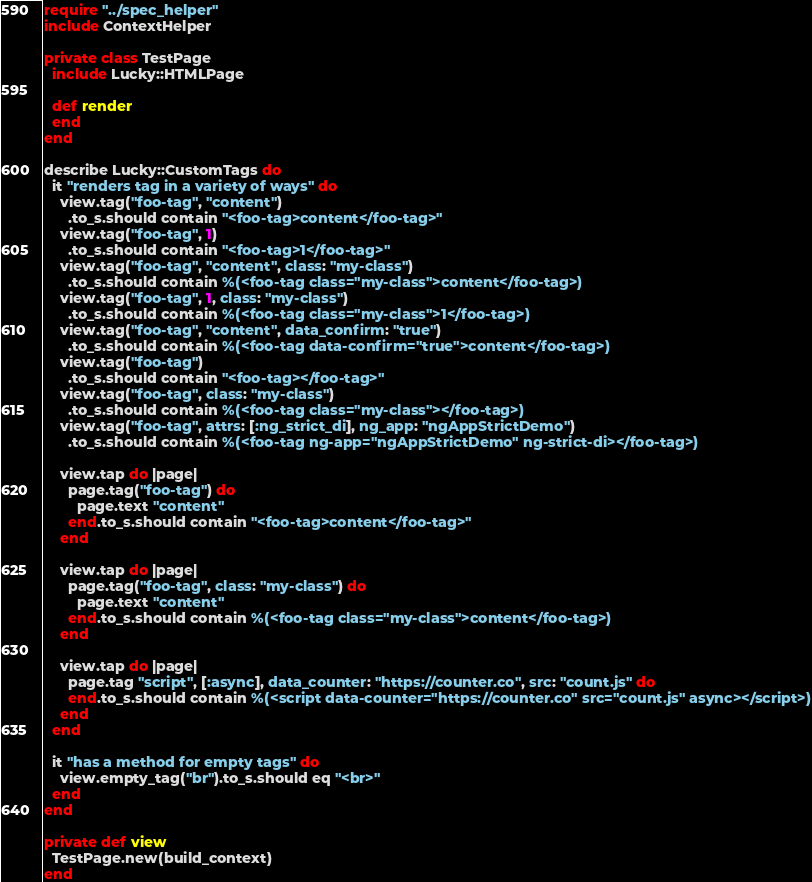Convert code to text. <code><loc_0><loc_0><loc_500><loc_500><_Crystal_>require "../spec_helper"
include ContextHelper

private class TestPage
  include Lucky::HTMLPage

  def render
  end
end

describe Lucky::CustomTags do
  it "renders tag in a variety of ways" do
    view.tag("foo-tag", "content")
      .to_s.should contain "<foo-tag>content</foo-tag>"
    view.tag("foo-tag", 1)
      .to_s.should contain "<foo-tag>1</foo-tag>"
    view.tag("foo-tag", "content", class: "my-class")
      .to_s.should contain %(<foo-tag class="my-class">content</foo-tag>)
    view.tag("foo-tag", 1, class: "my-class")
      .to_s.should contain %(<foo-tag class="my-class">1</foo-tag>)
    view.tag("foo-tag", "content", data_confirm: "true")
      .to_s.should contain %(<foo-tag data-confirm="true">content</foo-tag>)
    view.tag("foo-tag")
      .to_s.should contain "<foo-tag></foo-tag>"
    view.tag("foo-tag", class: "my-class")
      .to_s.should contain %(<foo-tag class="my-class"></foo-tag>)
    view.tag("foo-tag", attrs: [:ng_strict_di], ng_app: "ngAppStrictDemo")
      .to_s.should contain %(<foo-tag ng-app="ngAppStrictDemo" ng-strict-di></foo-tag>)

    view.tap do |page|
      page.tag("foo-tag") do
        page.text "content"
      end.to_s.should contain "<foo-tag>content</foo-tag>"
    end

    view.tap do |page|
      page.tag("foo-tag", class: "my-class") do
        page.text "content"
      end.to_s.should contain %(<foo-tag class="my-class">content</foo-tag>)
    end

    view.tap do |page|
      page.tag "script", [:async], data_counter: "https://counter.co", src: "count.js" do
      end.to_s.should contain %(<script data-counter="https://counter.co" src="count.js" async></script>)
    end
  end

  it "has a method for empty tags" do
    view.empty_tag("br").to_s.should eq "<br>"
  end
end

private def view
  TestPage.new(build_context)
end
</code> 